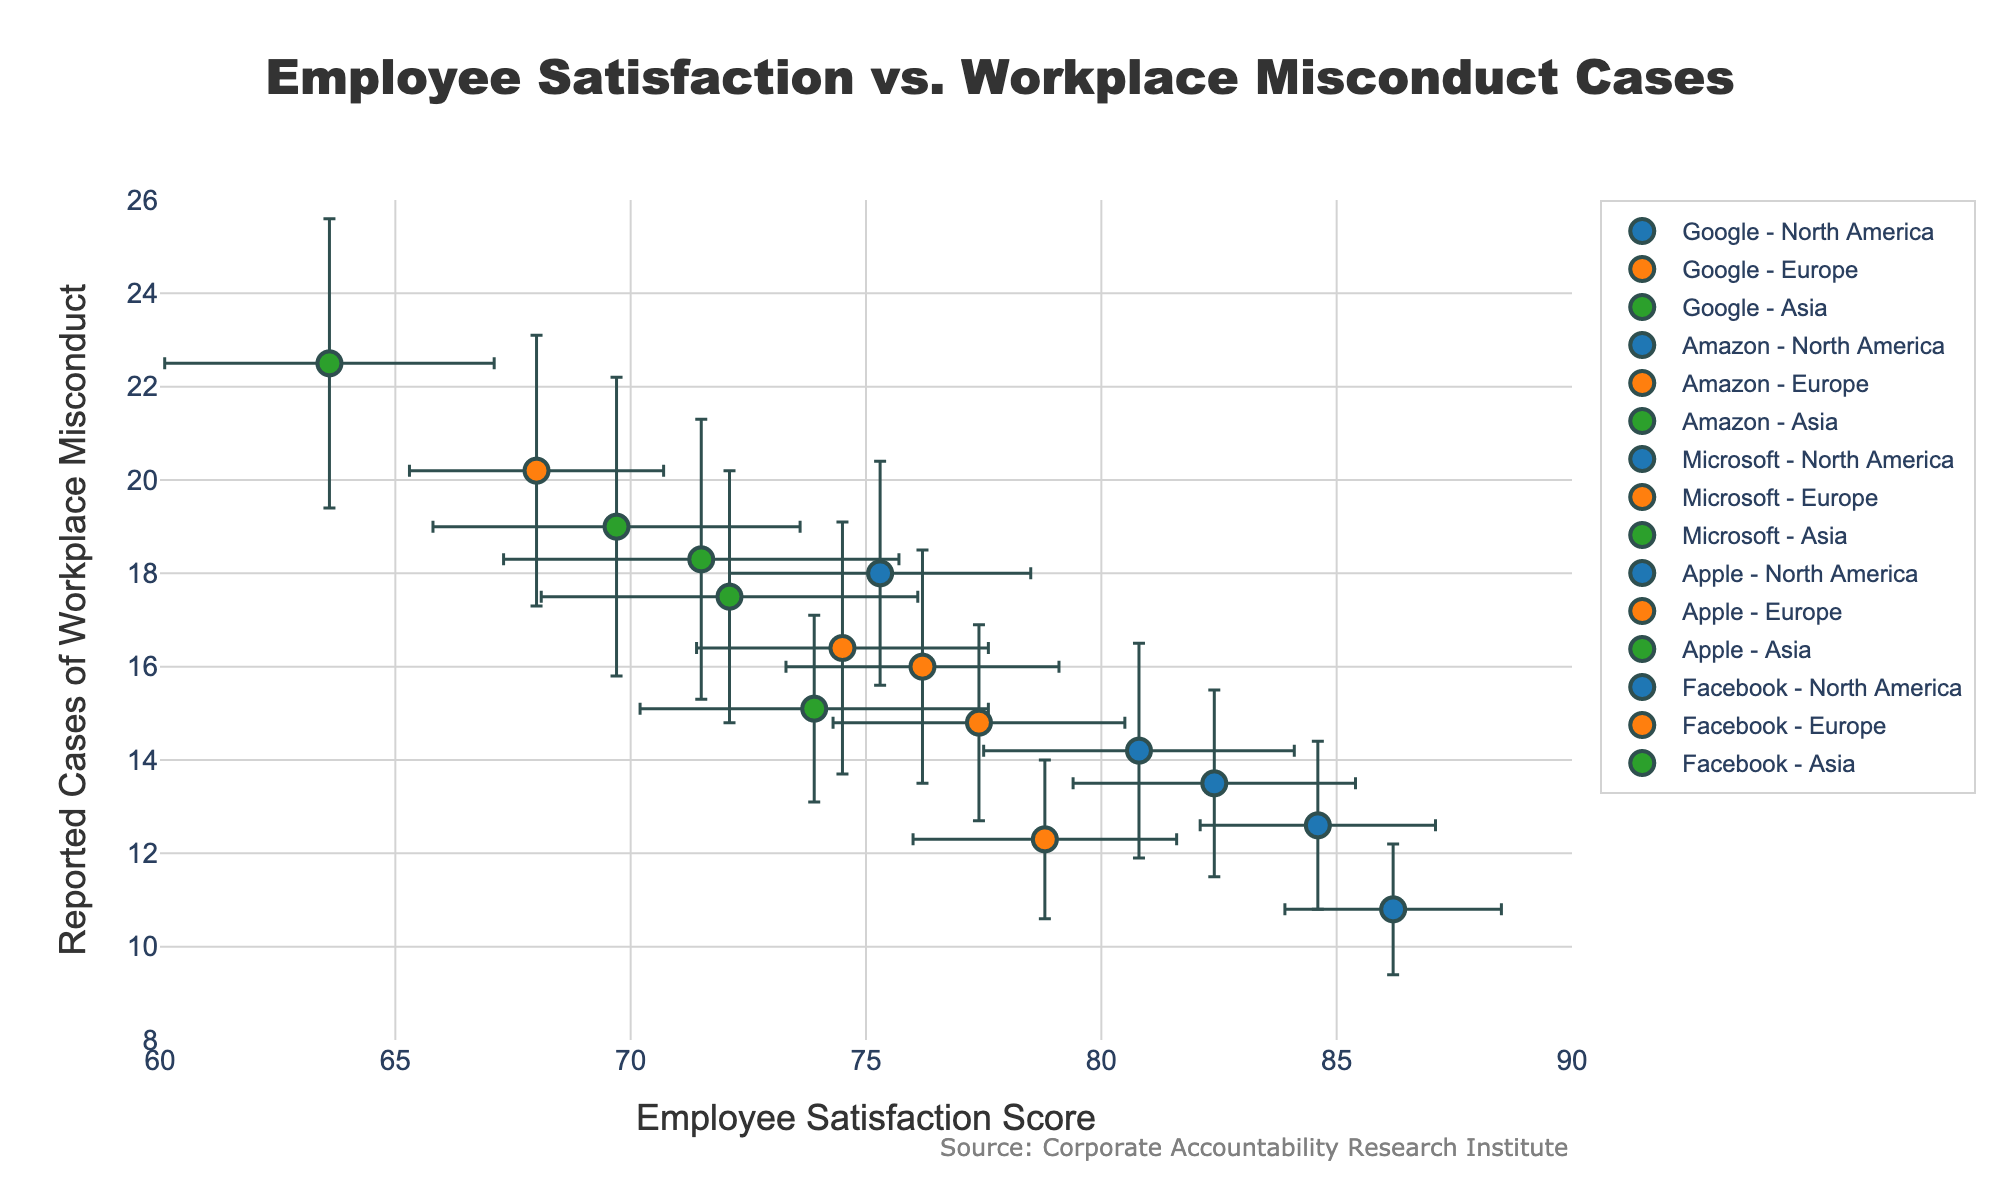What's the title of the figure? The title is displayed at the top center of the figure and usually summarizes the main insight.
Answer: Employee Satisfaction vs. Workplace Misconduct Cases What are the axes labeled as? The bottom horizontal line (x-axis) shows Employee Satisfaction Score, and the left vertical line (y-axis) shows Reported Cases of Workplace Misconduct.
Answer: Employee Satisfaction Score, Reported Cases of Workplace Misconduct How many data points are plotted in the figure? Each data point represents a company's performance in a specific region, and there are 5 companies and 3 regions, resulting in a total of 5 * 3 = 15 points.
Answer: 15 Which company in North America has the highest Employee Satisfaction Score? By looking at the x-axis values for data points labeled as North America, Microsoft shows the highest Employee Satisfaction Score.
Answer: Microsoft What is the approximate average Employee Satisfaction Score for companies in Europe? Add up the scores for each company in Europe (Google: 77.4, Amazon: 68.0, Microsoft: 78.8, Apple: 76.2, Facebook: 74.5) and then divide by 5: (77.4 + 68.0 + 78.8 + 76.2 + 74.5) / 5.
Answer: 75.0 Which region shows the highest average workplace misconduct cases for Google? Compare the y-axis values of Google across the three regions (North America: 12.6, Europe: 14.8, Asia: 17.5) and see that Asia is the highest.
Answer: Asia How does Apple in Europe compare to Facebook in North America in terms of workplace misconduct? Apple in Europe has around 16.0 workplace misconduct cases, while Facebook in North America has around 14.2 cases. So, Apple in Europe reports more misconduct than Facebook in North America.
Answer: Apple in Europe has higher misconduct What is the difference in employee satisfaction scores between Amazon in Asia and Google in North America? Amazon in Asia has around 63.6, and Google in North America has around 84.6. The difference is 84.6 - 63.6.
Answer: 21.0 Is there a general trend in reported workplace misconduct cases across regions? Examine the y-axis values and see that Asia has the highest values, followed by Europe and then North America, indicating an increasing trend from North America to Asia.
Answer: Asia > Europe > North America What can be inferred about Microsoft in terms of employee satisfaction and workplace misconduct reported across regions? Microsoft in North America appears as the highest in employee satisfaction and lowest in workplace misconduct. Europe follows with moderate values, and Asia shows the lowest satisfaction and higher misconduct.
Answer: High satisfaction, low misconduct in North America; moderate in Europe; low satisfaction, high misconduct in Asia 